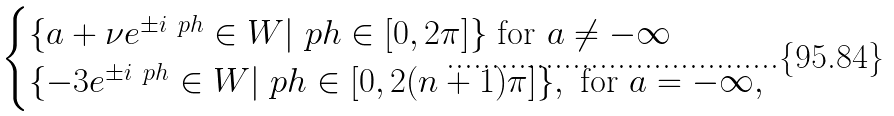Convert formula to latex. <formula><loc_0><loc_0><loc_500><loc_500>\begin{cases} \{ a + \nu e ^ { \pm i \ p h } \in W | \ p h \in [ 0 , 2 \pi ] \} \text { for } a \not = - \infty \\ \{ - 3 e ^ { \pm i \ p h } \in W | \ p h \in [ 0 , 2 ( n + 1 ) \pi ] \} , \text { for } a = - \infty , \end{cases}</formula> 